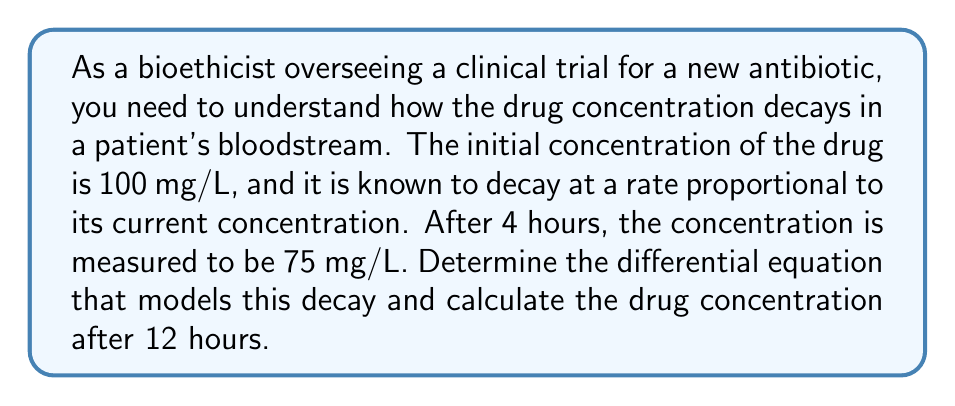Help me with this question. Let's approach this step-by-step:

1) Let $C(t)$ be the concentration of the drug at time $t$ (in hours).

2) We're told that the decay rate is proportional to the current concentration. This can be expressed as:

   $$\frac{dC}{dt} = -kC$$

   where $k$ is the decay constant.

3) We know two points: 
   At $t=0$, $C(0) = 100$ mg/L
   At $t=4$, $C(4) = 75$ mg/L

4) The solution to this differential equation is:

   $$C(t) = C_0e^{-kt}$$

   where $C_0$ is the initial concentration.

5) We can use the second point to find $k$:

   $$75 = 100e^{-4k}$$

6) Solving for $k$:

   $$\ln(0.75) = -4k$$
   $$k = -\frac{\ln(0.75)}{4} \approx 0.0718$$

7) Now we have our complete model:

   $$C(t) = 100e^{-0.0718t}$$

8) To find the concentration after 12 hours, we substitute $t=12$:

   $$C(12) = 100e^{-0.0718(12)} \approx 42.3$$
Answer: The differential equation modeling the drug decay is $\frac{dC}{dt} = -0.0718C$, and the drug concentration after 12 hours is approximately 42.3 mg/L. 